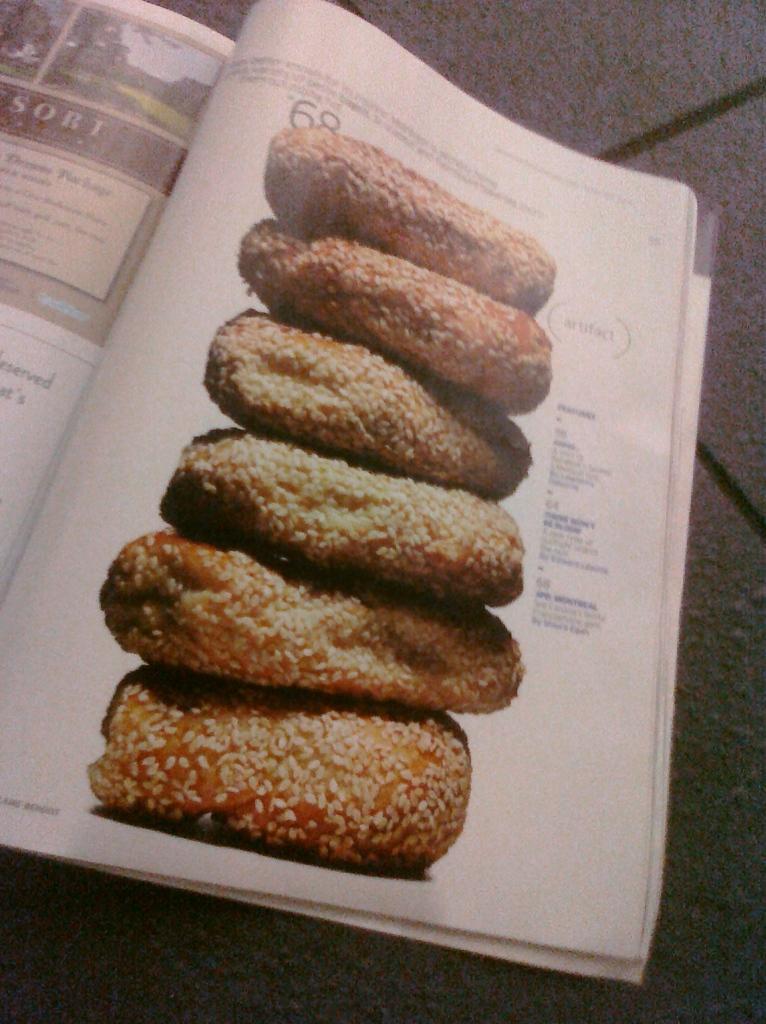How would you summarize this image in a sentence or two? In this image we can see a book on the floor, there are images and text in the book.  